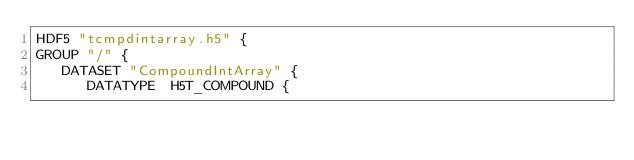<code> <loc_0><loc_0><loc_500><loc_500><_SQL_>HDF5 "tcmpdintarray.h5" {
GROUP "/" {
   DATASET "CompoundIntArray" {
      DATATYPE  H5T_COMPOUND {</code> 